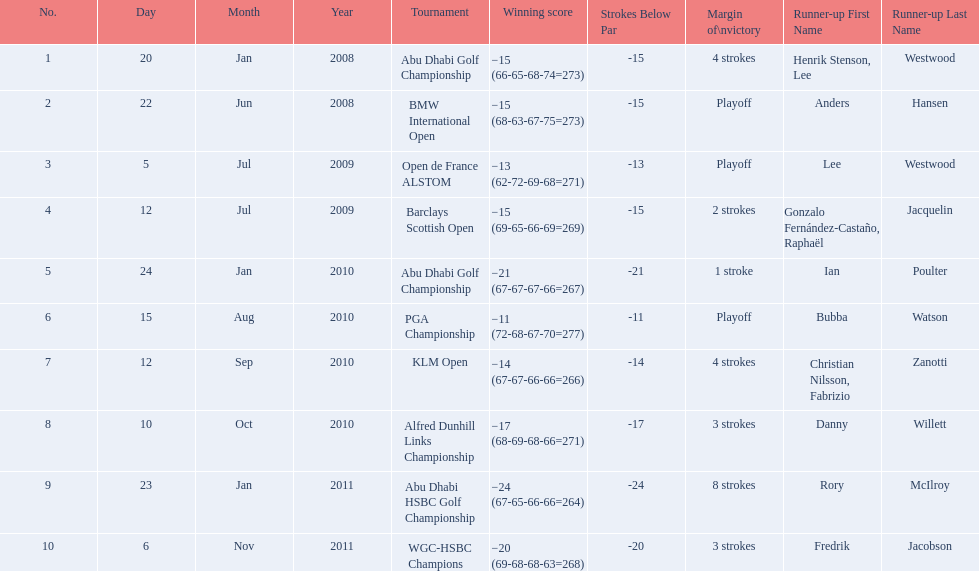What were the margins of victories of the tournaments? 4 strokes, Playoff, Playoff, 2 strokes, 1 stroke, Playoff, 4 strokes, 3 strokes, 8 strokes, 3 strokes. Of these, what was the margin of victory of the klm and the barklay 2 strokes, 4 strokes. What were the difference between these? 2 strokes. 